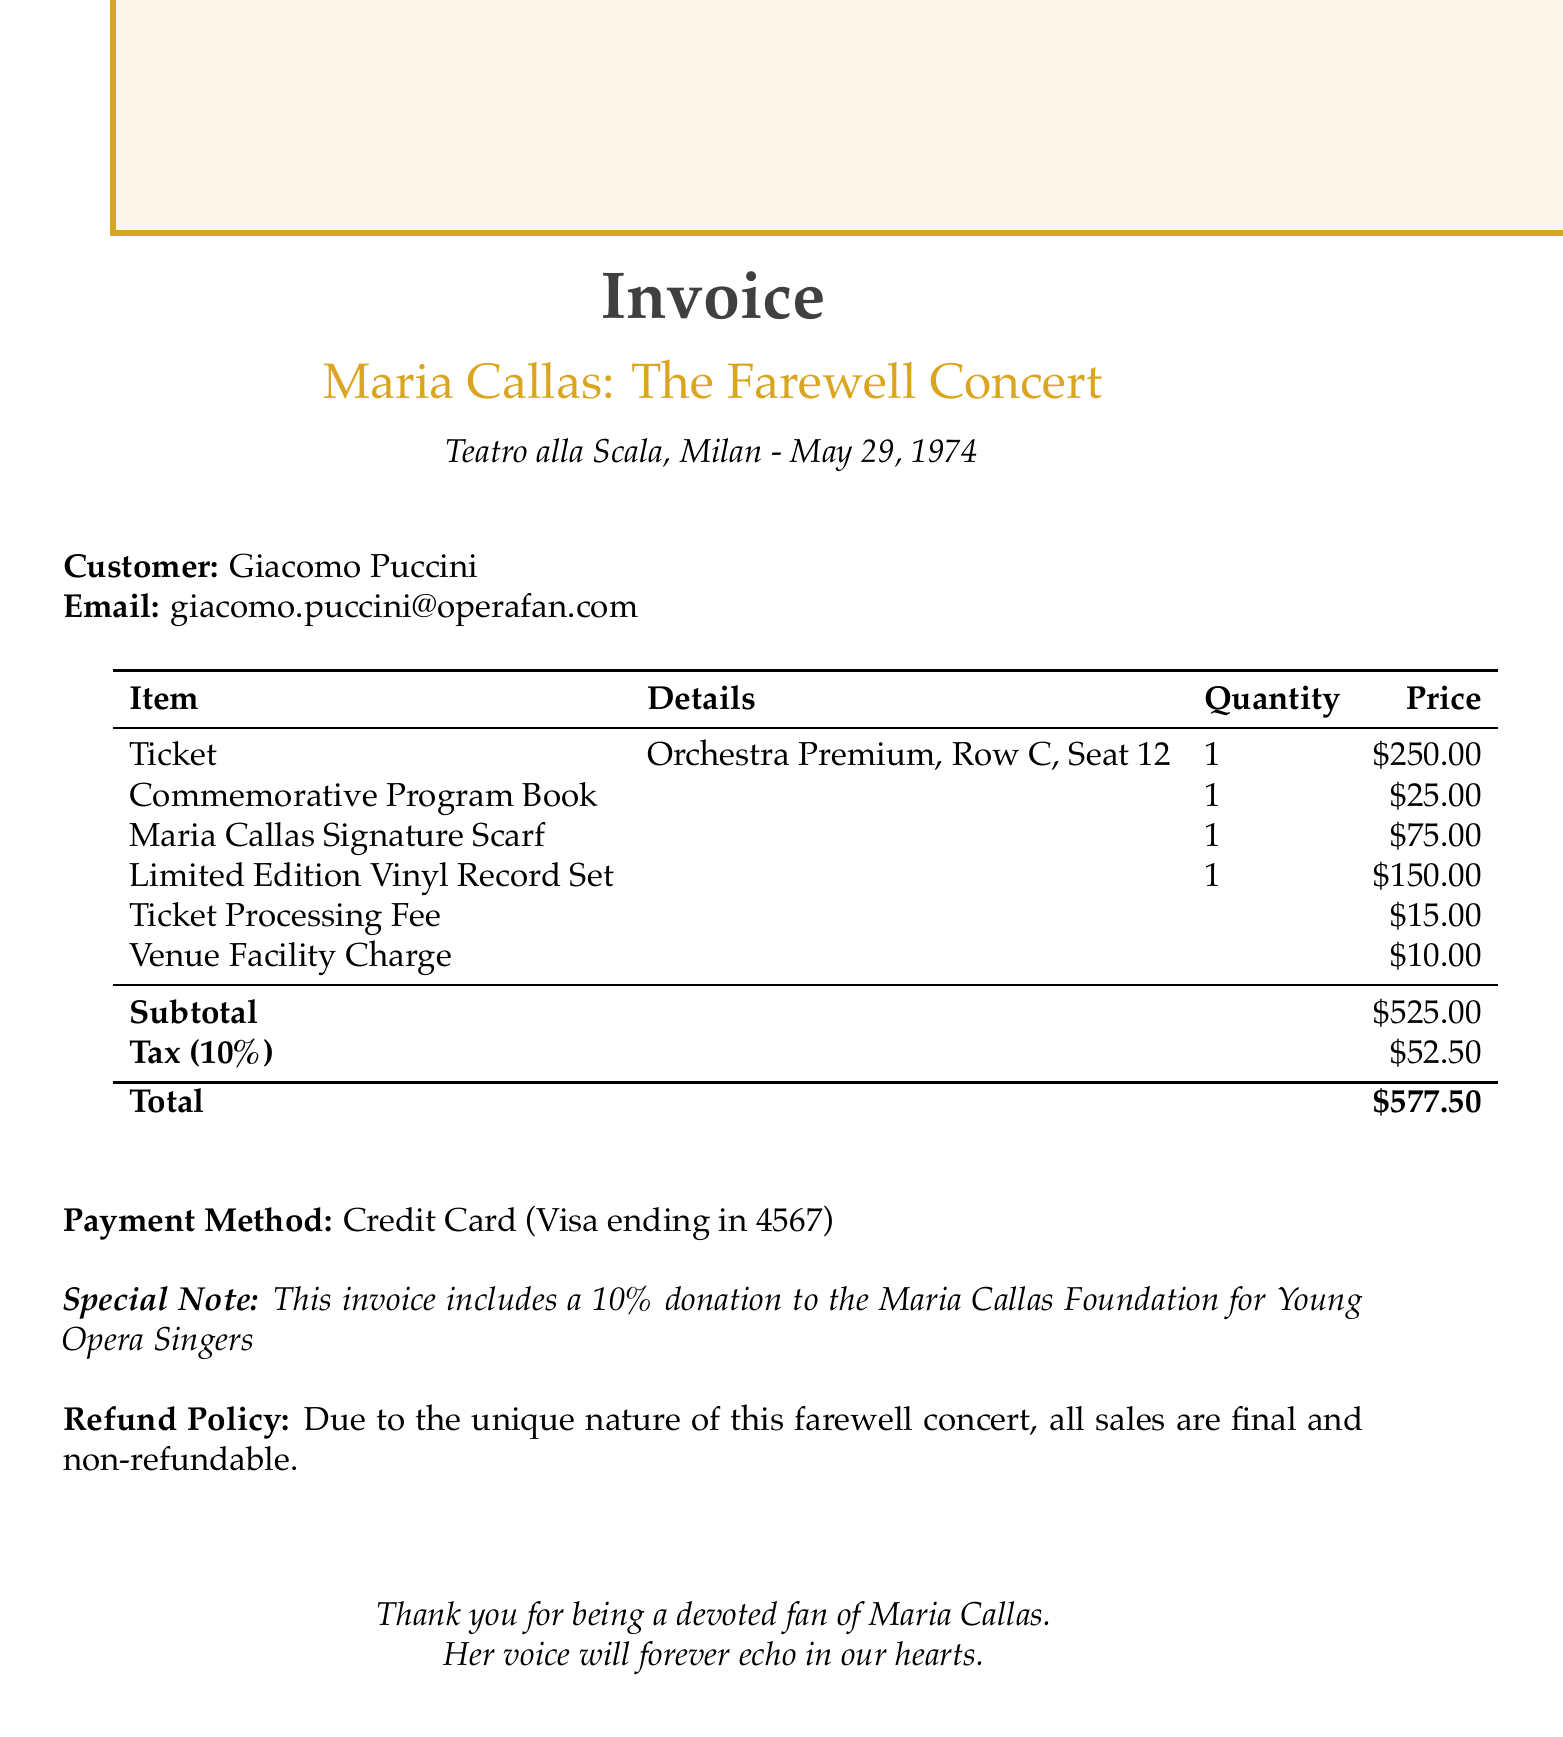What is the event name? The event name is prominently displayed at the top of the invoice.
Answer: Maria Callas: The Farewell Concert Where is the concert venue? The concert venue is mentioned in the introductory section of the invoice.
Answer: Teatro alla Scala, Milan What is the ticket price? The ticket price is listed alongside the ticket details in the invoice.
Answer: $250.00 How much was charged for merchandise? The total charge for merchandise can be obtained by adding the individual merchandise prices.
Answer: $250.00 What is the total amount due? The total amount is provided at the bottom of the invoice, summarizing all costs and fees.
Answer: $577.50 What special note is included in the invoice? The special note is a significant piece of information regarding contributions mentioned at the bottom of the invoice.
Answer: This invoice includes a 10% donation to the Maria Callas Foundation for Young Opera Singers What is the refund policy stated in the document? The refund policy specifies the terms surrounding sales for the concert tickets.
Answer: All sales are final and non-refundable How many items were purchased in total? The number of items can be determined by counting the merchandise and ticket entries in the invoice.
Answer: 4 items 